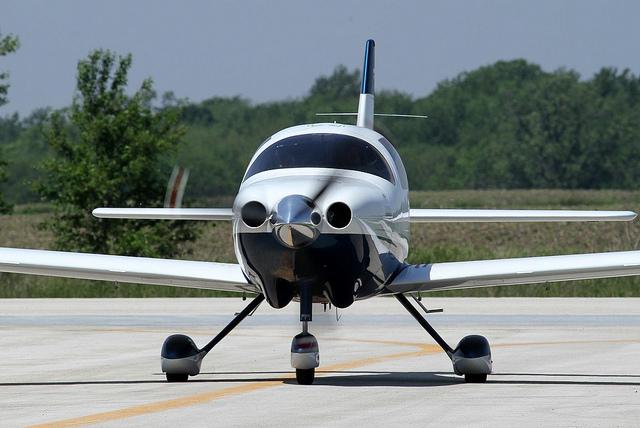What kind of vehicle is this?
Write a very short answer. Plane. Is the plan on concrete?
Keep it brief. Yes. Is the plane moving?
Give a very brief answer. Yes. 